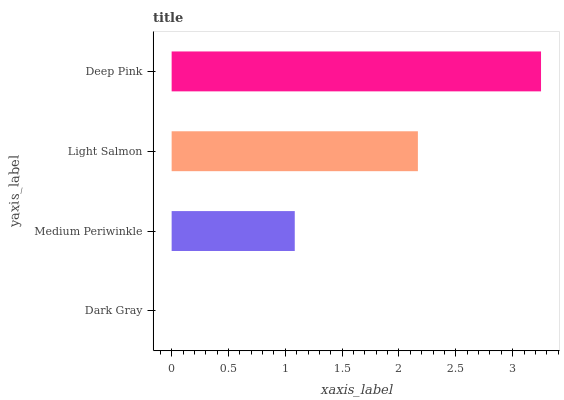Is Dark Gray the minimum?
Answer yes or no. Yes. Is Deep Pink the maximum?
Answer yes or no. Yes. Is Medium Periwinkle the minimum?
Answer yes or no. No. Is Medium Periwinkle the maximum?
Answer yes or no. No. Is Medium Periwinkle greater than Dark Gray?
Answer yes or no. Yes. Is Dark Gray less than Medium Periwinkle?
Answer yes or no. Yes. Is Dark Gray greater than Medium Periwinkle?
Answer yes or no. No. Is Medium Periwinkle less than Dark Gray?
Answer yes or no. No. Is Light Salmon the high median?
Answer yes or no. Yes. Is Medium Periwinkle the low median?
Answer yes or no. Yes. Is Medium Periwinkle the high median?
Answer yes or no. No. Is Deep Pink the low median?
Answer yes or no. No. 